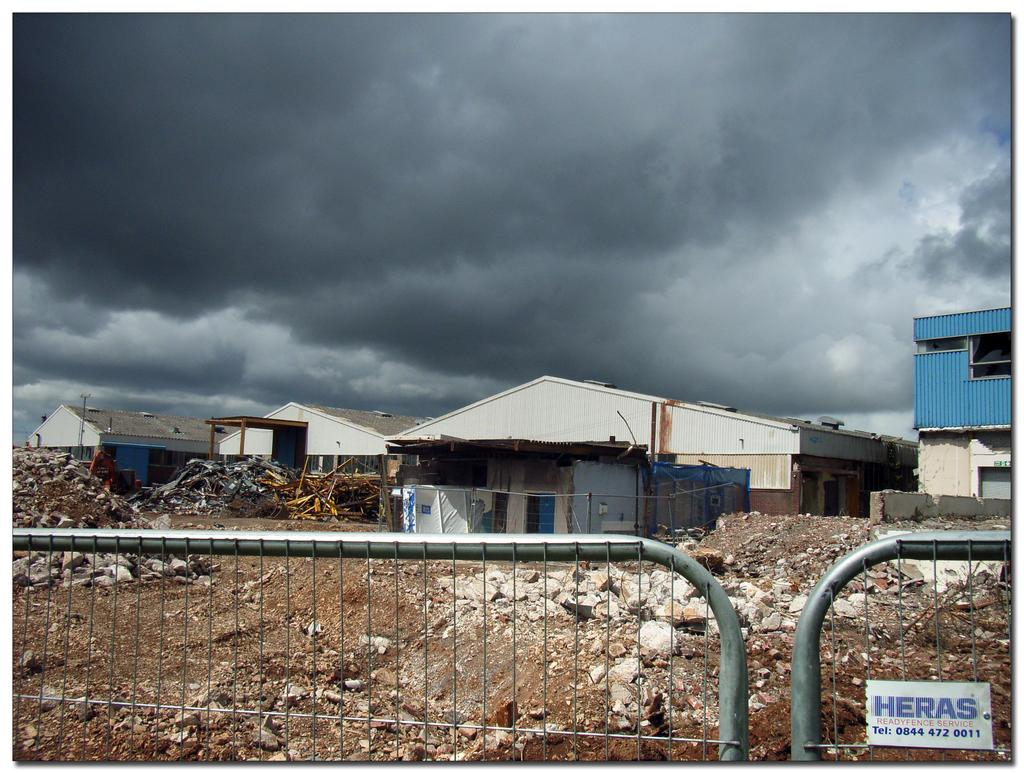What is located in the foreground of the image? There is fencing in the foreground of the image. What structures can be seen in the center of the image? There are houses in the center of the image. What type of ground is visible in the image? There is soil visible in the image. What is visible in the sky at the top of the image? There are clouds at the top of the image. Where is the nest located in the image? There is no nest present in the image. Who delivered the parcel in the image? There is no parcel present in the image. What arithmetic problem is being solved in the image? There is no arithmetic problem present in the image. 